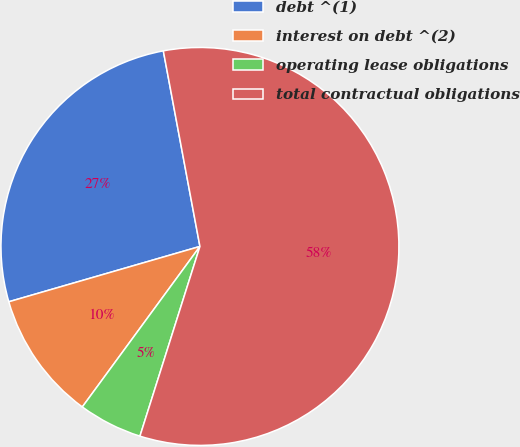<chart> <loc_0><loc_0><loc_500><loc_500><pie_chart><fcel>debt ^(1)<fcel>interest on debt ^(2)<fcel>operating lease obligations<fcel>total contractual obligations<nl><fcel>26.54%<fcel>10.45%<fcel>5.19%<fcel>57.82%<nl></chart> 